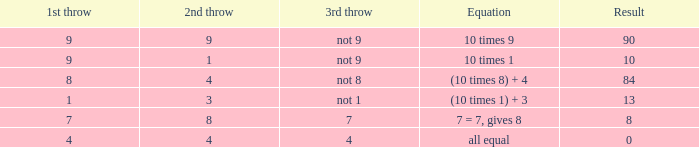I'm looking to parse the entire table for insights. Could you assist me with that? {'header': ['1st throw', '2nd throw', '3rd throw', 'Equation', 'Result'], 'rows': [['9', '9', 'not 9', '10 times 9', '90'], ['9', '1', 'not 9', '10 times 1', '10'], ['8', '4', 'not 8', '(10 times 8) + 4', '84'], ['1', '3', 'not 1', '(10 times 1) + 3', '13'], ['7', '8', '7', '7 = 7, gives 8', '8'], ['4', '4', '4', 'all equal', '0']]} If the equation is (10 times 8) + 4, what would be the 2nd throw? 4.0. 